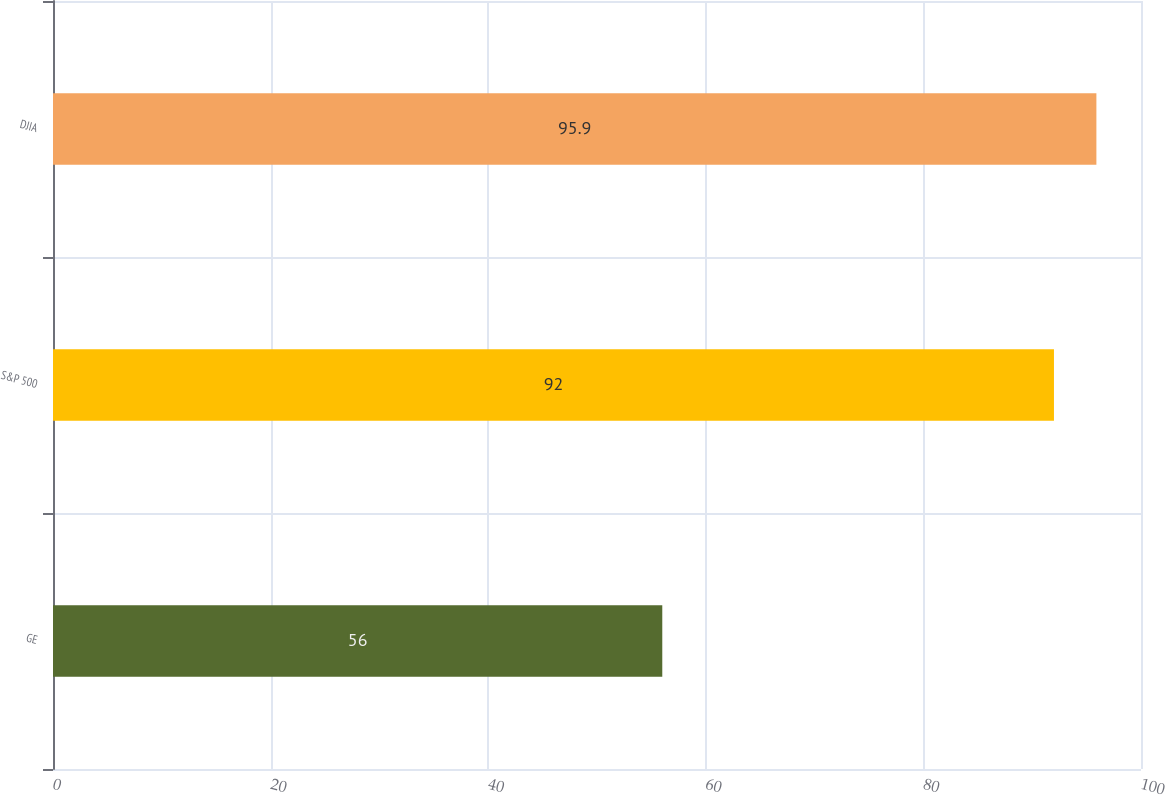Convert chart. <chart><loc_0><loc_0><loc_500><loc_500><bar_chart><fcel>GE<fcel>S&P 500<fcel>DJIA<nl><fcel>56<fcel>92<fcel>95.9<nl></chart> 